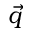<formula> <loc_0><loc_0><loc_500><loc_500>\vec { q }</formula> 